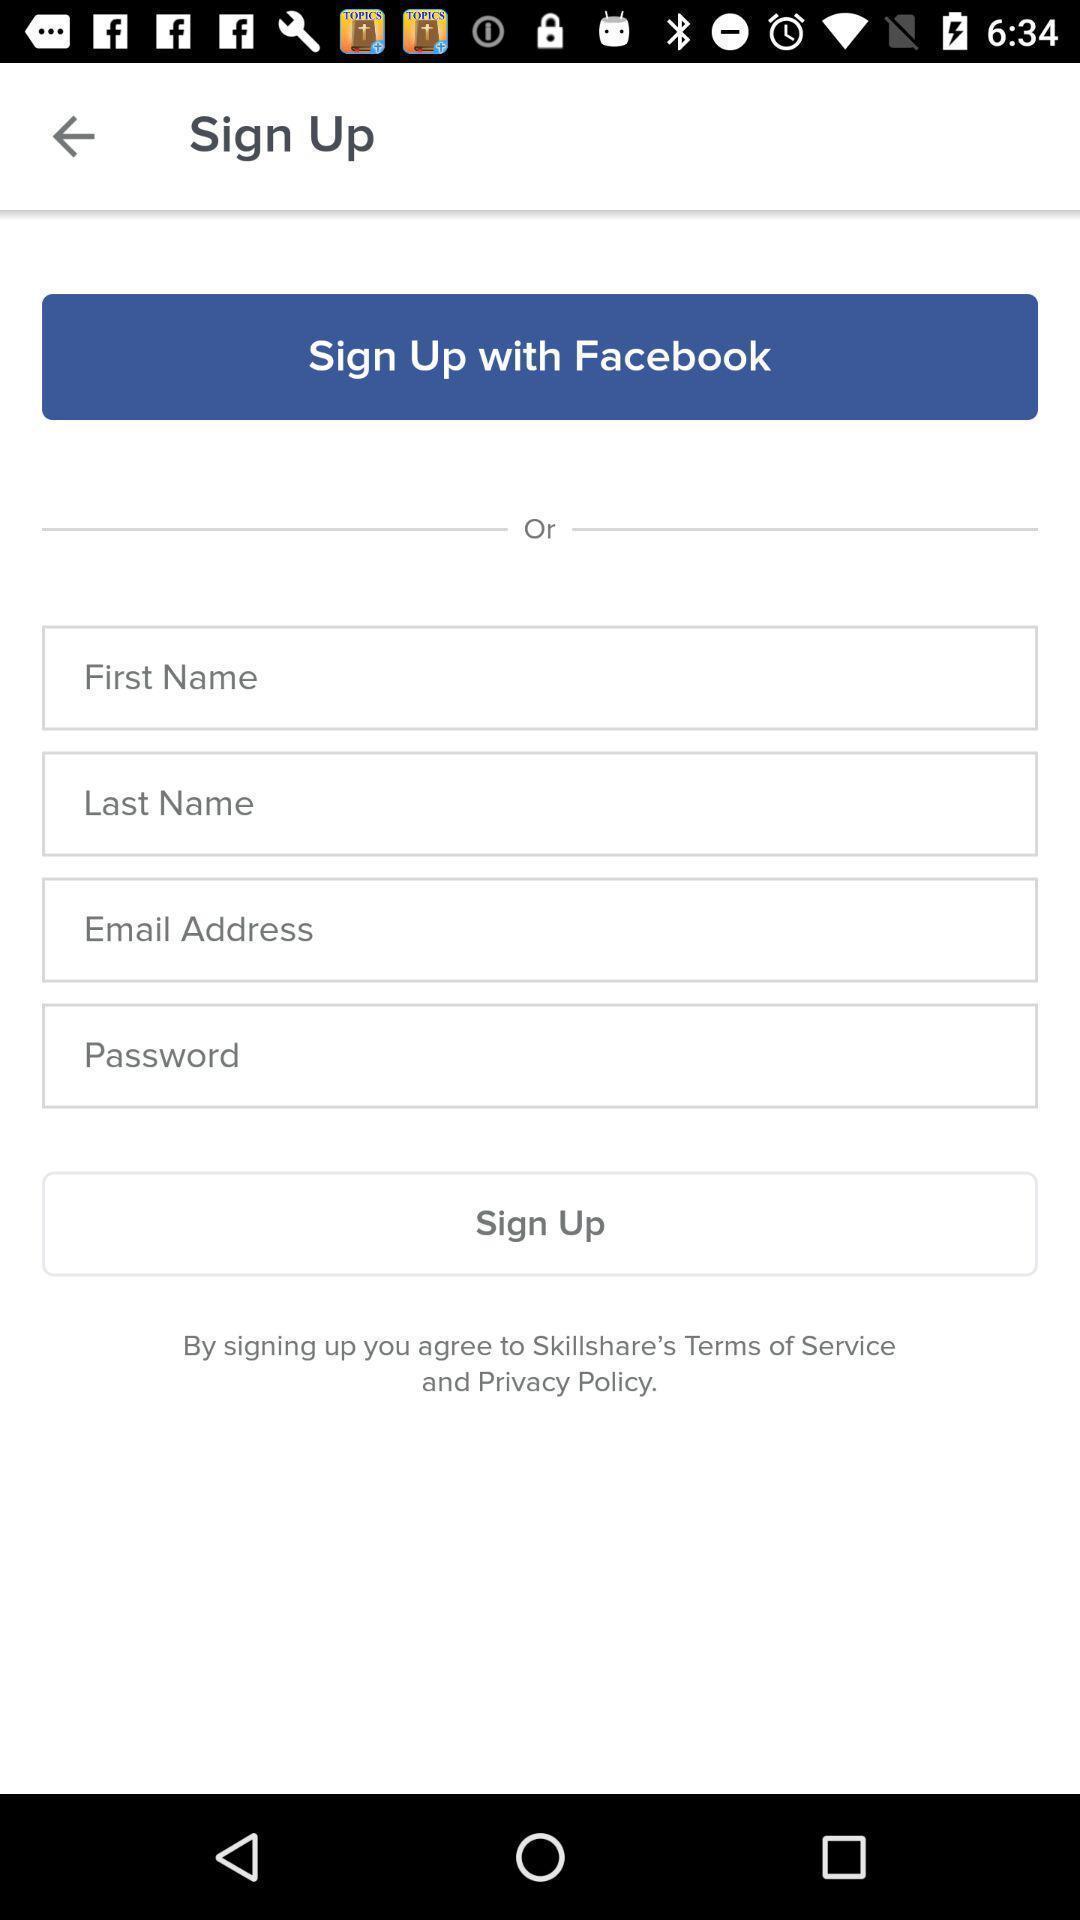Summarize the main components in this picture. Signup page of a learning app. 